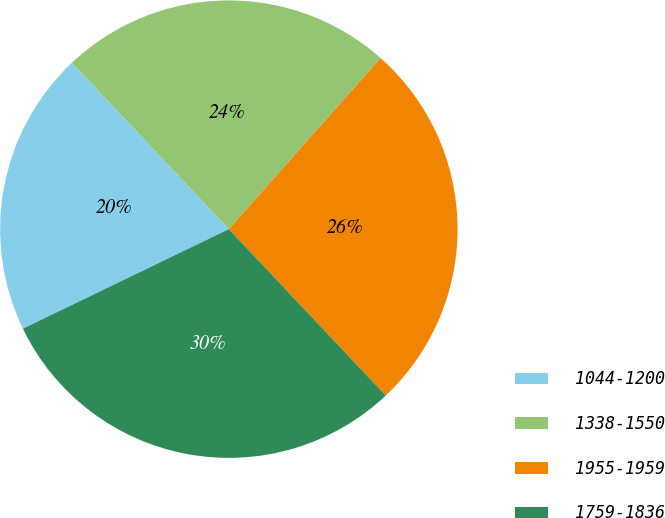<chart> <loc_0><loc_0><loc_500><loc_500><pie_chart><fcel>1044-1200<fcel>1338-1550<fcel>1955-1959<fcel>1759-1836<nl><fcel>20.13%<fcel>23.58%<fcel>26.42%<fcel>29.87%<nl></chart> 